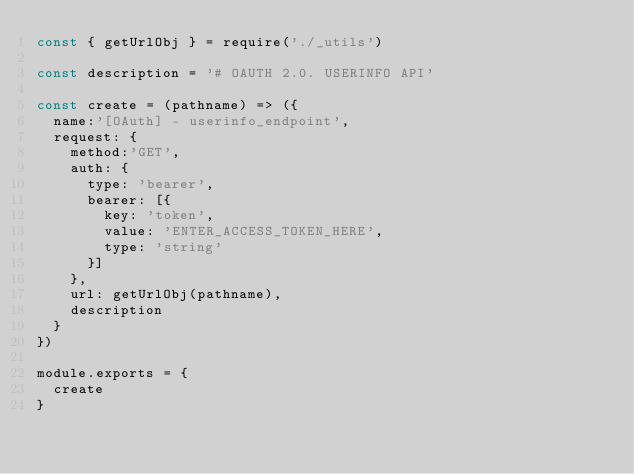Convert code to text. <code><loc_0><loc_0><loc_500><loc_500><_JavaScript_>const { getUrlObj } = require('./_utils')

const description = '# OAUTH 2.0. USERINFO API'

const create = (pathname) => ({
	name:'[OAuth] - userinfo_endpoint',
	request: {
		method:'GET',
		auth: {
			type: 'bearer',
			bearer: [{
				key: 'token',
				value: 'ENTER_ACCESS_TOKEN_HERE',
				type: 'string'
			}]
		},
		url: getUrlObj(pathname),
		description
	}
})

module.exports = {
	create
}</code> 